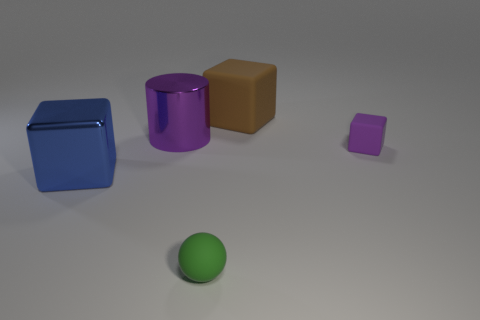What is the size of the thing that is the same color as the large cylinder?
Your response must be concise. Small. What color is the rubber block that is the same size as the matte ball?
Provide a short and direct response. Purple. What number of matte objects are large blue blocks or purple things?
Your response must be concise. 1. What shape is the large metal thing that is the same color as the small matte block?
Your answer should be very brief. Cylinder. What number of blue blocks are the same size as the green thing?
Provide a short and direct response. 0. What is the color of the thing that is both in front of the big purple shiny thing and left of the small green sphere?
Provide a short and direct response. Blue. How many objects are either tiny purple shiny balls or green rubber objects?
Your answer should be compact. 1. What number of big objects are green blocks or cylinders?
Provide a short and direct response. 1. Is there any other thing that has the same color as the metallic cylinder?
Give a very brief answer. Yes. There is a matte thing that is behind the ball and in front of the big purple cylinder; what is its size?
Your response must be concise. Small. 